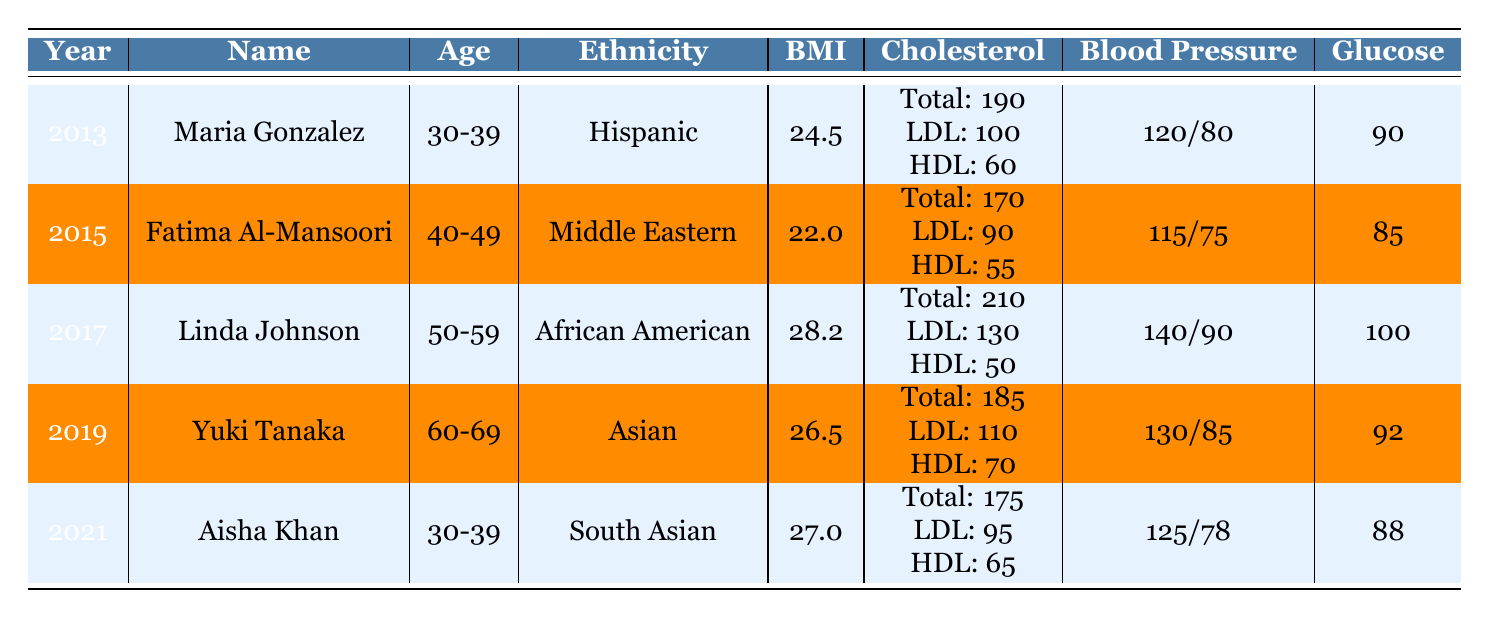What is the BMI of Maria Gonzalez? The table specifies Maria Gonzalez's BMI in the row corresponding to the year 2013. According to that row, her BMI is listed as 24.5.
Answer: 24.5 Which woman had a cholesterol total lower than 200? By looking through the cholesterol total values in the table, we find that both Maria Gonzalez (190) and Fatima Al-Mansoori (170) had total cholesterol levels below 200.
Answer: Maria Gonzalez, Fatima Al-Mansoori What is the average glucose level across all screenings? To find the average, we sum the glucose levels for all women: (90 + 85 + 100 + 92 + 88) = 455. There are 5 total readings, so the average glucose level is 455/5 = 91.
Answer: 91 Did Linda Johnson have a systolic blood pressure reading above 130? The table lists Linda Johnson's systolic blood pressure as 140. Since 140 is greater than 130, the answer is yes.
Answer: Yes Which woman, categorized as Asian, had the lowest blood pressure? The only Asian woman in the table is Yuki Tanaka, with a blood pressure reading of 130/85. To determine if this is the lowest, we compare it with blood pressure readings of others: Maria Gonzalez (120/80), Fatima Al-Mansoori (115/75), Linda Johnson (140/90), and Aisha Khan (125/78). Maria Gonzalez has the lowest systolic and diastolic readings.
Answer: Maria Gonzalez What is the difference in total cholesterol between Linda Johnson and Fatima Al-Mansoori? From the table, Linda Johnson's cholesterol total is 210, and Fatima Al-Mansoori's is 170. The difference is calculated as 210 - 170 = 40.
Answer: 40 Did Aisha Khan have a BMI greater than 26? Aisha Khan's BMI is noted as 27, which is greater than 26. Thus, the answer is yes.
Answer: Yes Which screening type did Maria Gonzalez undergo? The screening type for Maria Gonzalez is recorded in her row for 2013, where it states "Annual Checkup."
Answer: Annual Checkup What age group did Fatima Al-Mansoori belong to during her screening in 2015? The table clearly indicates Fatima Al-Mansoori's age group as 40-49, as this is listed in the same row as her other health metrics.
Answer: 40-49 